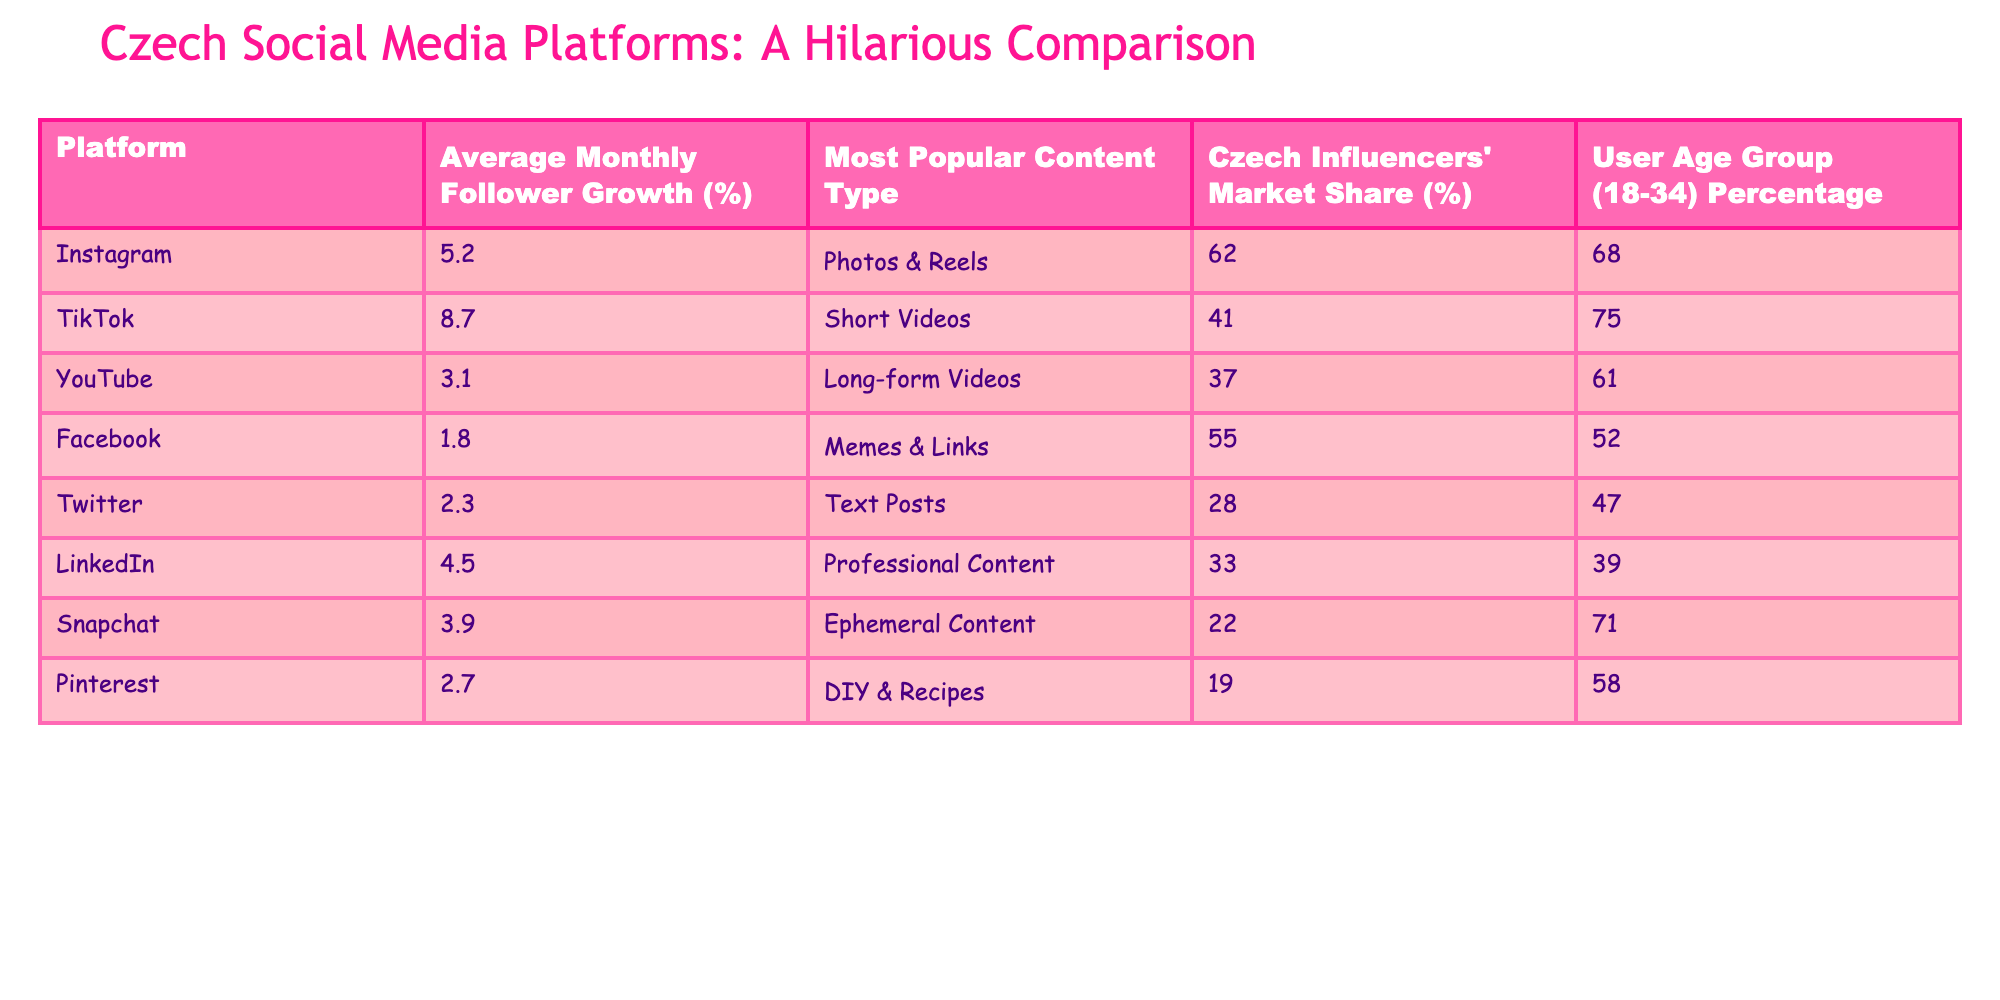What platform has the highest average monthly follower growth? The table shows that TikTok has the highest average monthly follower growth at 8.7%.
Answer: TikTok What is the average monthly follower growth for Facebook? According to the table, Facebook has an average monthly follower growth of 1.8%.
Answer: 1.8% Which content type is most popular on Instagram? The table indicates that the most popular content type on Instagram is Photos & Reels.
Answer: Photos & Reels True or False: Instagram has a higher follower growth compared to YouTube. The average monthly follower growth for Instagram is 5.2%, while YouTube's is 3.1%. Since 5.2% is greater than 3.1%, the statement is true.
Answer: True What is the difference in average monthly follower growth between TikTok and Snapchat? TikTok's average growth is 8.7% and Snapchat's is 3.9%. The difference is 8.7% - 3.9% = 4.8%.
Answer: 4.8% Which social media platform has the least market share among Czech influencers? The table shows that Pinterest has the least market share at 19%.
Answer: Pinterest How do the follower growth rates of LinkedIn and Twitter compare? LinkedIn has a growth rate of 4.5%, while Twitter has 2.3%. LinkedIn’s rate is higher.
Answer: LinkedIn’s growth rate is higher If we sum the market shares of Instagram and TikTok, what do we get? Instagram's market share is 62%, and TikTok's is 41%. So, 62% + 41% = 103%.
Answer: 103% What percentage of users aged 18-34 are on TikTok? The table indicates that 75% of TikTok users are aged 18-34.
Answer: 75% Is the average monthly follower growth for YouTube greater than that of LinkedIn? YouTube's growth is 3.1%, and LinkedIn's is 4.5%. Since 3.1% is lower than 4.5%, the statement is false.
Answer: False Which platform has the lowest user age group percentage (18-34)? The table shows that Twitter has the lowest percentage of users aged 18-34 at 47%.
Answer: Twitter 